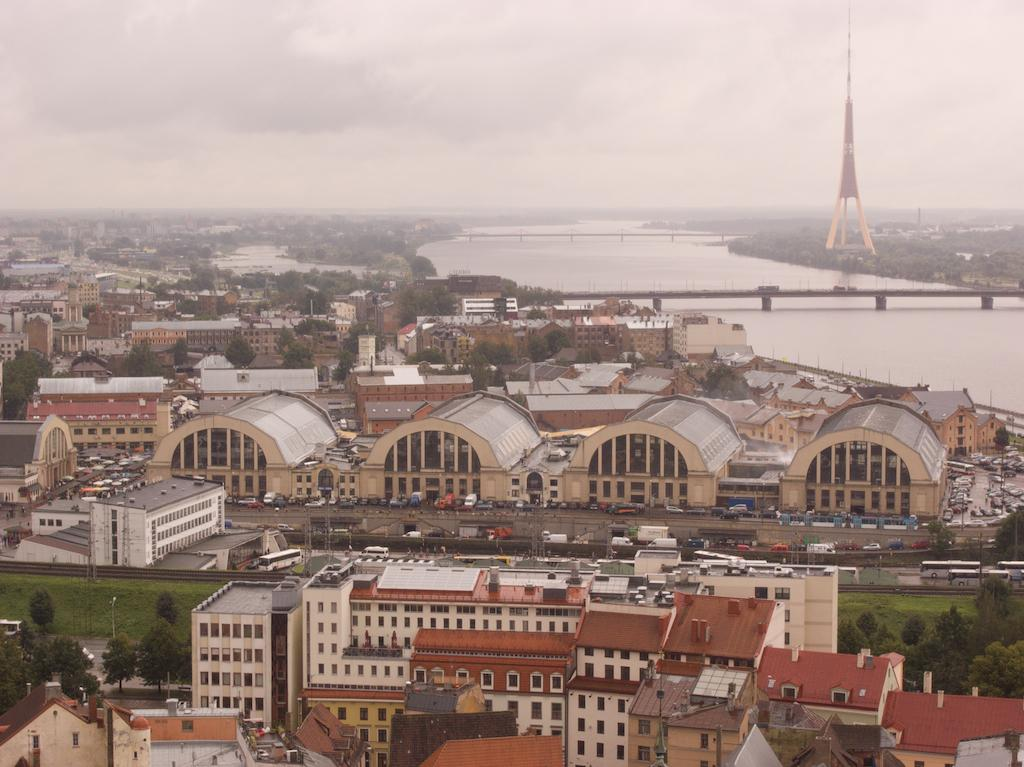What type of view is provided in the image? The image is a top view. What structures can be seen in the image? There are buildings, a bridge, and a tower in the image. What type of vegetation is present in the image? There are trees and grass in the image. What is happening on the road in the image? Vehicles are moving on the road in the image. What can be seen in the water in the image? The image does not provide a close enough view to see anything specific in the water. What is the condition of the sky in the background? The sky in the background is cloudy. What type of glass is used to make the observation deck on the tower in the image? There is no observation deck mentioned in the image, and therefore no glass can be associated with it. 